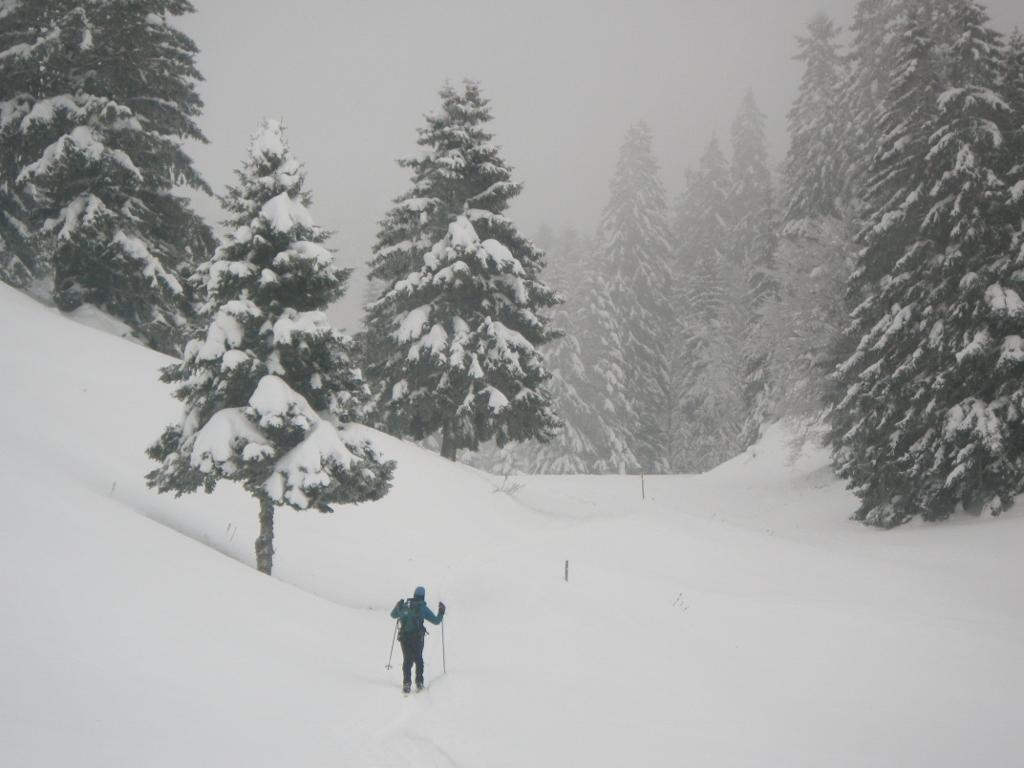What is the person in the image holding? The person in the image is holding sticks. What type of natural environment is depicted in the image? There are trees and snow in the image, suggesting a wintery forest setting. What type of base is the governor using to store books in the image? There is no base or governor present in the image; it features a person holding sticks in a snowy forest setting. 